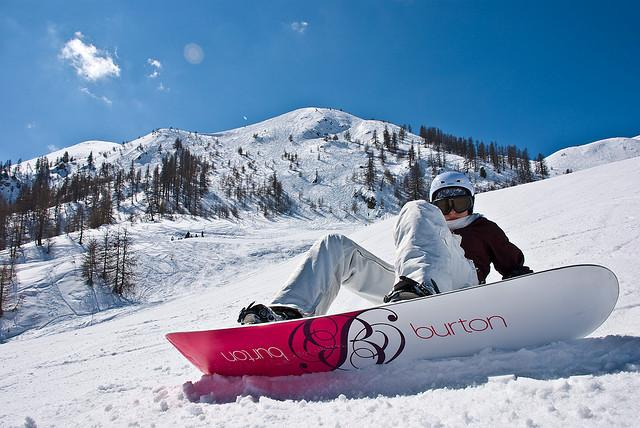Who crafted the thing on the person's feet? Please explain your reasoning. company. The name of the company is one the snowboard. 